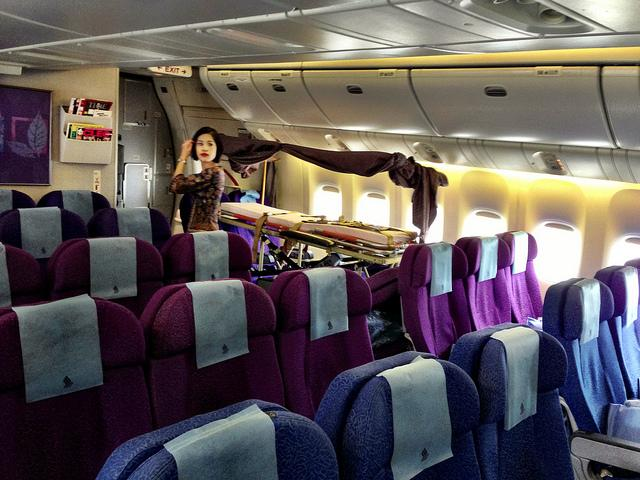Which country does this airline likely belong to? japan 